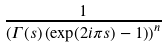Convert formula to latex. <formula><loc_0><loc_0><loc_500><loc_500>\frac { 1 } { \left ( \Gamma ( s ) \left ( \exp ( 2 i \pi s ) - 1 \right ) \right ) ^ { n } }</formula> 